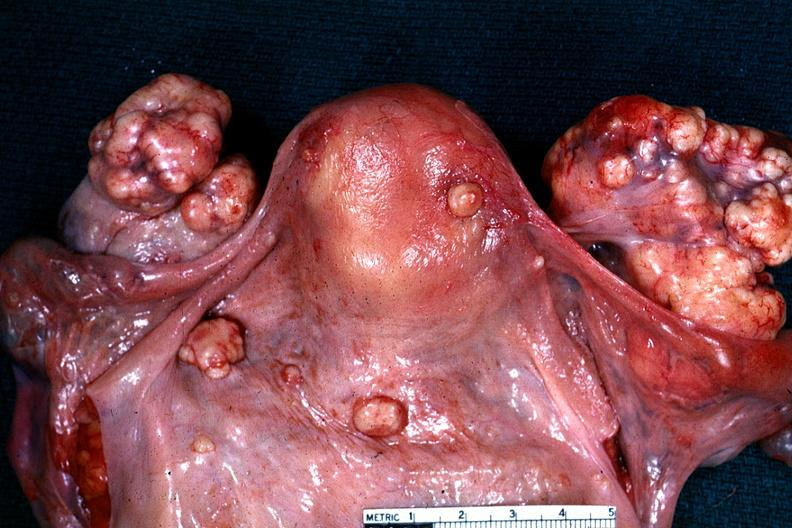what does this image show?
Answer the question using a single word or phrase. Excellent example of peritoneal carcinomatosis with implants on serosal surfaces of uterus and ovaries said to be an adenocarcinoma 